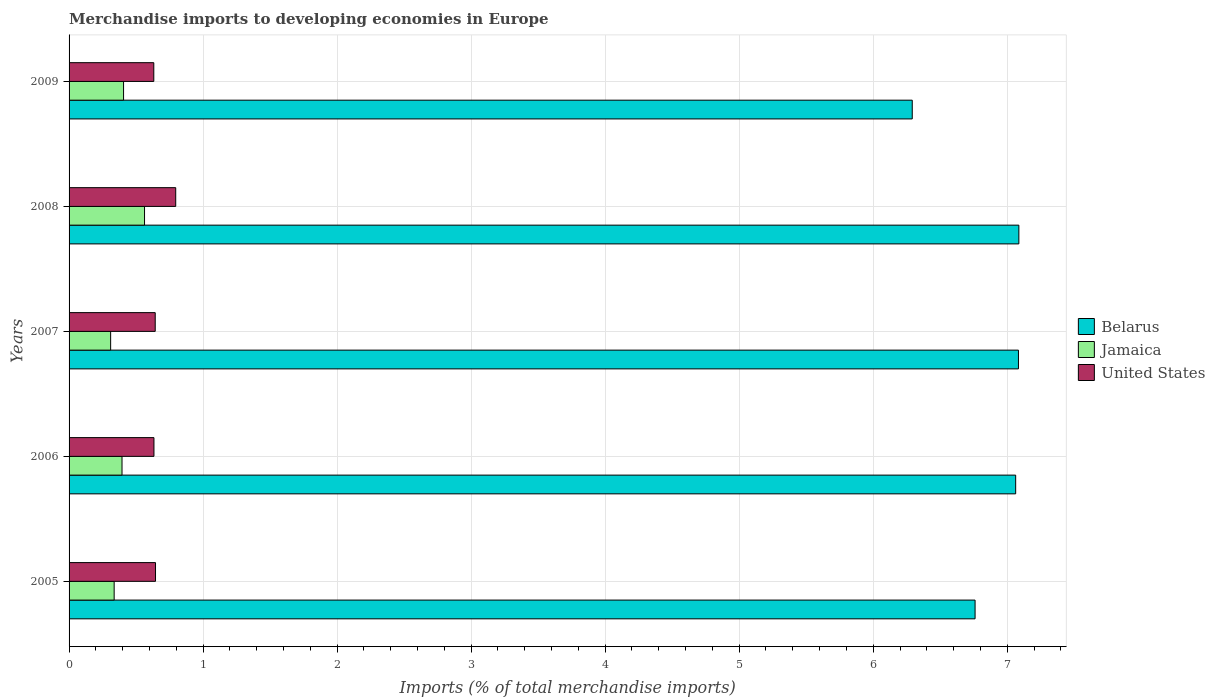How many different coloured bars are there?
Your answer should be compact. 3. How many groups of bars are there?
Ensure brevity in your answer.  5. How many bars are there on the 2nd tick from the bottom?
Give a very brief answer. 3. What is the label of the 1st group of bars from the top?
Keep it short and to the point. 2009. In how many cases, is the number of bars for a given year not equal to the number of legend labels?
Provide a succinct answer. 0. What is the percentage total merchandise imports in Belarus in 2005?
Give a very brief answer. 6.76. Across all years, what is the maximum percentage total merchandise imports in Belarus?
Offer a very short reply. 7.09. Across all years, what is the minimum percentage total merchandise imports in Jamaica?
Provide a succinct answer. 0.31. In which year was the percentage total merchandise imports in United States maximum?
Offer a terse response. 2008. What is the total percentage total merchandise imports in Jamaica in the graph?
Your answer should be very brief. 2.01. What is the difference between the percentage total merchandise imports in Belarus in 2005 and that in 2009?
Keep it short and to the point. 0.47. What is the difference between the percentage total merchandise imports in United States in 2006 and the percentage total merchandise imports in Jamaica in 2009?
Your answer should be compact. 0.23. What is the average percentage total merchandise imports in Jamaica per year?
Ensure brevity in your answer.  0.4. In the year 2009, what is the difference between the percentage total merchandise imports in Jamaica and percentage total merchandise imports in United States?
Your answer should be compact. -0.23. What is the ratio of the percentage total merchandise imports in Jamaica in 2006 to that in 2008?
Offer a terse response. 0.7. What is the difference between the highest and the second highest percentage total merchandise imports in Belarus?
Provide a succinct answer. 0. What is the difference between the highest and the lowest percentage total merchandise imports in Jamaica?
Your answer should be compact. 0.25. Is the sum of the percentage total merchandise imports in Jamaica in 2005 and 2007 greater than the maximum percentage total merchandise imports in Belarus across all years?
Ensure brevity in your answer.  No. What does the 3rd bar from the top in 2005 represents?
Make the answer very short. Belarus. What does the 1st bar from the bottom in 2009 represents?
Make the answer very short. Belarus. Is it the case that in every year, the sum of the percentage total merchandise imports in Belarus and percentage total merchandise imports in United States is greater than the percentage total merchandise imports in Jamaica?
Your response must be concise. Yes. How many bars are there?
Make the answer very short. 15. How many years are there in the graph?
Your answer should be compact. 5. Are the values on the major ticks of X-axis written in scientific E-notation?
Offer a very short reply. No. Does the graph contain any zero values?
Offer a very short reply. No. Does the graph contain grids?
Give a very brief answer. Yes. How are the legend labels stacked?
Offer a very short reply. Vertical. What is the title of the graph?
Your answer should be compact. Merchandise imports to developing economies in Europe. Does "Mozambique" appear as one of the legend labels in the graph?
Give a very brief answer. No. What is the label or title of the X-axis?
Keep it short and to the point. Imports (% of total merchandise imports). What is the label or title of the Y-axis?
Make the answer very short. Years. What is the Imports (% of total merchandise imports) in Belarus in 2005?
Your answer should be compact. 6.76. What is the Imports (% of total merchandise imports) of Jamaica in 2005?
Provide a short and direct response. 0.34. What is the Imports (% of total merchandise imports) of United States in 2005?
Provide a short and direct response. 0.65. What is the Imports (% of total merchandise imports) of Belarus in 2006?
Your answer should be very brief. 7.06. What is the Imports (% of total merchandise imports) of Jamaica in 2006?
Make the answer very short. 0.39. What is the Imports (% of total merchandise imports) in United States in 2006?
Offer a very short reply. 0.63. What is the Imports (% of total merchandise imports) of Belarus in 2007?
Your answer should be very brief. 7.08. What is the Imports (% of total merchandise imports) of Jamaica in 2007?
Your answer should be compact. 0.31. What is the Imports (% of total merchandise imports) of United States in 2007?
Ensure brevity in your answer.  0.64. What is the Imports (% of total merchandise imports) in Belarus in 2008?
Keep it short and to the point. 7.09. What is the Imports (% of total merchandise imports) in Jamaica in 2008?
Ensure brevity in your answer.  0.56. What is the Imports (% of total merchandise imports) of United States in 2008?
Provide a short and direct response. 0.8. What is the Imports (% of total merchandise imports) of Belarus in 2009?
Your response must be concise. 6.29. What is the Imports (% of total merchandise imports) in Jamaica in 2009?
Your response must be concise. 0.41. What is the Imports (% of total merchandise imports) in United States in 2009?
Provide a short and direct response. 0.63. Across all years, what is the maximum Imports (% of total merchandise imports) in Belarus?
Provide a succinct answer. 7.09. Across all years, what is the maximum Imports (% of total merchandise imports) in Jamaica?
Your answer should be very brief. 0.56. Across all years, what is the maximum Imports (% of total merchandise imports) of United States?
Your response must be concise. 0.8. Across all years, what is the minimum Imports (% of total merchandise imports) of Belarus?
Your answer should be compact. 6.29. Across all years, what is the minimum Imports (% of total merchandise imports) in Jamaica?
Offer a terse response. 0.31. Across all years, what is the minimum Imports (% of total merchandise imports) of United States?
Offer a terse response. 0.63. What is the total Imports (% of total merchandise imports) of Belarus in the graph?
Your answer should be compact. 34.29. What is the total Imports (% of total merchandise imports) of Jamaica in the graph?
Provide a short and direct response. 2.01. What is the total Imports (% of total merchandise imports) in United States in the graph?
Make the answer very short. 3.35. What is the difference between the Imports (% of total merchandise imports) of Belarus in 2005 and that in 2006?
Offer a terse response. -0.3. What is the difference between the Imports (% of total merchandise imports) of Jamaica in 2005 and that in 2006?
Provide a short and direct response. -0.06. What is the difference between the Imports (% of total merchandise imports) of United States in 2005 and that in 2006?
Ensure brevity in your answer.  0.01. What is the difference between the Imports (% of total merchandise imports) of Belarus in 2005 and that in 2007?
Give a very brief answer. -0.32. What is the difference between the Imports (% of total merchandise imports) of Jamaica in 2005 and that in 2007?
Offer a very short reply. 0.03. What is the difference between the Imports (% of total merchandise imports) in United States in 2005 and that in 2007?
Your answer should be very brief. 0. What is the difference between the Imports (% of total merchandise imports) of Belarus in 2005 and that in 2008?
Ensure brevity in your answer.  -0.33. What is the difference between the Imports (% of total merchandise imports) in Jamaica in 2005 and that in 2008?
Give a very brief answer. -0.23. What is the difference between the Imports (% of total merchandise imports) in United States in 2005 and that in 2008?
Keep it short and to the point. -0.15. What is the difference between the Imports (% of total merchandise imports) of Belarus in 2005 and that in 2009?
Keep it short and to the point. 0.47. What is the difference between the Imports (% of total merchandise imports) of Jamaica in 2005 and that in 2009?
Keep it short and to the point. -0.07. What is the difference between the Imports (% of total merchandise imports) in United States in 2005 and that in 2009?
Give a very brief answer. 0.01. What is the difference between the Imports (% of total merchandise imports) of Belarus in 2006 and that in 2007?
Ensure brevity in your answer.  -0.02. What is the difference between the Imports (% of total merchandise imports) in Jamaica in 2006 and that in 2007?
Make the answer very short. 0.08. What is the difference between the Imports (% of total merchandise imports) of United States in 2006 and that in 2007?
Offer a very short reply. -0.01. What is the difference between the Imports (% of total merchandise imports) of Belarus in 2006 and that in 2008?
Your answer should be very brief. -0.02. What is the difference between the Imports (% of total merchandise imports) of Jamaica in 2006 and that in 2008?
Make the answer very short. -0.17. What is the difference between the Imports (% of total merchandise imports) of United States in 2006 and that in 2008?
Ensure brevity in your answer.  -0.16. What is the difference between the Imports (% of total merchandise imports) in Belarus in 2006 and that in 2009?
Provide a succinct answer. 0.77. What is the difference between the Imports (% of total merchandise imports) of Jamaica in 2006 and that in 2009?
Keep it short and to the point. -0.01. What is the difference between the Imports (% of total merchandise imports) in United States in 2006 and that in 2009?
Your answer should be very brief. 0. What is the difference between the Imports (% of total merchandise imports) in Belarus in 2007 and that in 2008?
Give a very brief answer. -0. What is the difference between the Imports (% of total merchandise imports) in Jamaica in 2007 and that in 2008?
Offer a terse response. -0.25. What is the difference between the Imports (% of total merchandise imports) of United States in 2007 and that in 2008?
Offer a terse response. -0.15. What is the difference between the Imports (% of total merchandise imports) of Belarus in 2007 and that in 2009?
Your answer should be very brief. 0.79. What is the difference between the Imports (% of total merchandise imports) in Jamaica in 2007 and that in 2009?
Your answer should be compact. -0.1. What is the difference between the Imports (% of total merchandise imports) of United States in 2007 and that in 2009?
Your answer should be very brief. 0.01. What is the difference between the Imports (% of total merchandise imports) in Belarus in 2008 and that in 2009?
Give a very brief answer. 0.8. What is the difference between the Imports (% of total merchandise imports) of Jamaica in 2008 and that in 2009?
Your answer should be compact. 0.16. What is the difference between the Imports (% of total merchandise imports) of United States in 2008 and that in 2009?
Your answer should be compact. 0.16. What is the difference between the Imports (% of total merchandise imports) of Belarus in 2005 and the Imports (% of total merchandise imports) of Jamaica in 2006?
Offer a terse response. 6.37. What is the difference between the Imports (% of total merchandise imports) in Belarus in 2005 and the Imports (% of total merchandise imports) in United States in 2006?
Make the answer very short. 6.13. What is the difference between the Imports (% of total merchandise imports) in Jamaica in 2005 and the Imports (% of total merchandise imports) in United States in 2006?
Your answer should be compact. -0.3. What is the difference between the Imports (% of total merchandise imports) in Belarus in 2005 and the Imports (% of total merchandise imports) in Jamaica in 2007?
Offer a very short reply. 6.45. What is the difference between the Imports (% of total merchandise imports) in Belarus in 2005 and the Imports (% of total merchandise imports) in United States in 2007?
Your answer should be compact. 6.12. What is the difference between the Imports (% of total merchandise imports) of Jamaica in 2005 and the Imports (% of total merchandise imports) of United States in 2007?
Your response must be concise. -0.31. What is the difference between the Imports (% of total merchandise imports) in Belarus in 2005 and the Imports (% of total merchandise imports) in Jamaica in 2008?
Keep it short and to the point. 6.2. What is the difference between the Imports (% of total merchandise imports) of Belarus in 2005 and the Imports (% of total merchandise imports) of United States in 2008?
Offer a terse response. 5.96. What is the difference between the Imports (% of total merchandise imports) in Jamaica in 2005 and the Imports (% of total merchandise imports) in United States in 2008?
Ensure brevity in your answer.  -0.46. What is the difference between the Imports (% of total merchandise imports) of Belarus in 2005 and the Imports (% of total merchandise imports) of Jamaica in 2009?
Your answer should be compact. 6.35. What is the difference between the Imports (% of total merchandise imports) in Belarus in 2005 and the Imports (% of total merchandise imports) in United States in 2009?
Your answer should be compact. 6.13. What is the difference between the Imports (% of total merchandise imports) in Jamaica in 2005 and the Imports (% of total merchandise imports) in United States in 2009?
Your response must be concise. -0.3. What is the difference between the Imports (% of total merchandise imports) of Belarus in 2006 and the Imports (% of total merchandise imports) of Jamaica in 2007?
Keep it short and to the point. 6.75. What is the difference between the Imports (% of total merchandise imports) of Belarus in 2006 and the Imports (% of total merchandise imports) of United States in 2007?
Provide a succinct answer. 6.42. What is the difference between the Imports (% of total merchandise imports) of Jamaica in 2006 and the Imports (% of total merchandise imports) of United States in 2007?
Provide a succinct answer. -0.25. What is the difference between the Imports (% of total merchandise imports) in Belarus in 2006 and the Imports (% of total merchandise imports) in Jamaica in 2008?
Provide a succinct answer. 6.5. What is the difference between the Imports (% of total merchandise imports) of Belarus in 2006 and the Imports (% of total merchandise imports) of United States in 2008?
Make the answer very short. 6.27. What is the difference between the Imports (% of total merchandise imports) in Jamaica in 2006 and the Imports (% of total merchandise imports) in United States in 2008?
Provide a short and direct response. -0.4. What is the difference between the Imports (% of total merchandise imports) in Belarus in 2006 and the Imports (% of total merchandise imports) in Jamaica in 2009?
Offer a very short reply. 6.66. What is the difference between the Imports (% of total merchandise imports) of Belarus in 2006 and the Imports (% of total merchandise imports) of United States in 2009?
Keep it short and to the point. 6.43. What is the difference between the Imports (% of total merchandise imports) in Jamaica in 2006 and the Imports (% of total merchandise imports) in United States in 2009?
Offer a terse response. -0.24. What is the difference between the Imports (% of total merchandise imports) in Belarus in 2007 and the Imports (% of total merchandise imports) in Jamaica in 2008?
Make the answer very short. 6.52. What is the difference between the Imports (% of total merchandise imports) in Belarus in 2007 and the Imports (% of total merchandise imports) in United States in 2008?
Your response must be concise. 6.29. What is the difference between the Imports (% of total merchandise imports) of Jamaica in 2007 and the Imports (% of total merchandise imports) of United States in 2008?
Give a very brief answer. -0.49. What is the difference between the Imports (% of total merchandise imports) in Belarus in 2007 and the Imports (% of total merchandise imports) in Jamaica in 2009?
Offer a terse response. 6.68. What is the difference between the Imports (% of total merchandise imports) of Belarus in 2007 and the Imports (% of total merchandise imports) of United States in 2009?
Provide a short and direct response. 6.45. What is the difference between the Imports (% of total merchandise imports) of Jamaica in 2007 and the Imports (% of total merchandise imports) of United States in 2009?
Give a very brief answer. -0.32. What is the difference between the Imports (% of total merchandise imports) of Belarus in 2008 and the Imports (% of total merchandise imports) of Jamaica in 2009?
Ensure brevity in your answer.  6.68. What is the difference between the Imports (% of total merchandise imports) in Belarus in 2008 and the Imports (% of total merchandise imports) in United States in 2009?
Give a very brief answer. 6.45. What is the difference between the Imports (% of total merchandise imports) of Jamaica in 2008 and the Imports (% of total merchandise imports) of United States in 2009?
Give a very brief answer. -0.07. What is the average Imports (% of total merchandise imports) in Belarus per year?
Offer a very short reply. 6.86. What is the average Imports (% of total merchandise imports) of Jamaica per year?
Offer a terse response. 0.4. What is the average Imports (% of total merchandise imports) in United States per year?
Offer a very short reply. 0.67. In the year 2005, what is the difference between the Imports (% of total merchandise imports) of Belarus and Imports (% of total merchandise imports) of Jamaica?
Ensure brevity in your answer.  6.42. In the year 2005, what is the difference between the Imports (% of total merchandise imports) in Belarus and Imports (% of total merchandise imports) in United States?
Provide a short and direct response. 6.12. In the year 2005, what is the difference between the Imports (% of total merchandise imports) of Jamaica and Imports (% of total merchandise imports) of United States?
Your response must be concise. -0.31. In the year 2006, what is the difference between the Imports (% of total merchandise imports) in Belarus and Imports (% of total merchandise imports) in Jamaica?
Provide a succinct answer. 6.67. In the year 2006, what is the difference between the Imports (% of total merchandise imports) in Belarus and Imports (% of total merchandise imports) in United States?
Give a very brief answer. 6.43. In the year 2006, what is the difference between the Imports (% of total merchandise imports) in Jamaica and Imports (% of total merchandise imports) in United States?
Provide a short and direct response. -0.24. In the year 2007, what is the difference between the Imports (% of total merchandise imports) in Belarus and Imports (% of total merchandise imports) in Jamaica?
Offer a very short reply. 6.77. In the year 2007, what is the difference between the Imports (% of total merchandise imports) of Belarus and Imports (% of total merchandise imports) of United States?
Provide a short and direct response. 6.44. In the year 2007, what is the difference between the Imports (% of total merchandise imports) of Jamaica and Imports (% of total merchandise imports) of United States?
Offer a terse response. -0.33. In the year 2008, what is the difference between the Imports (% of total merchandise imports) in Belarus and Imports (% of total merchandise imports) in Jamaica?
Keep it short and to the point. 6.52. In the year 2008, what is the difference between the Imports (% of total merchandise imports) in Belarus and Imports (% of total merchandise imports) in United States?
Your answer should be very brief. 6.29. In the year 2008, what is the difference between the Imports (% of total merchandise imports) in Jamaica and Imports (% of total merchandise imports) in United States?
Offer a terse response. -0.23. In the year 2009, what is the difference between the Imports (% of total merchandise imports) of Belarus and Imports (% of total merchandise imports) of Jamaica?
Your answer should be compact. 5.88. In the year 2009, what is the difference between the Imports (% of total merchandise imports) of Belarus and Imports (% of total merchandise imports) of United States?
Provide a short and direct response. 5.66. In the year 2009, what is the difference between the Imports (% of total merchandise imports) in Jamaica and Imports (% of total merchandise imports) in United States?
Ensure brevity in your answer.  -0.23. What is the ratio of the Imports (% of total merchandise imports) of Belarus in 2005 to that in 2006?
Provide a short and direct response. 0.96. What is the ratio of the Imports (% of total merchandise imports) in Jamaica in 2005 to that in 2006?
Your answer should be compact. 0.85. What is the ratio of the Imports (% of total merchandise imports) in United States in 2005 to that in 2006?
Offer a terse response. 1.02. What is the ratio of the Imports (% of total merchandise imports) in Belarus in 2005 to that in 2007?
Give a very brief answer. 0.95. What is the ratio of the Imports (% of total merchandise imports) of Jamaica in 2005 to that in 2007?
Ensure brevity in your answer.  1.08. What is the ratio of the Imports (% of total merchandise imports) in Belarus in 2005 to that in 2008?
Provide a short and direct response. 0.95. What is the ratio of the Imports (% of total merchandise imports) of Jamaica in 2005 to that in 2008?
Provide a short and direct response. 0.6. What is the ratio of the Imports (% of total merchandise imports) in United States in 2005 to that in 2008?
Provide a succinct answer. 0.81. What is the ratio of the Imports (% of total merchandise imports) of Belarus in 2005 to that in 2009?
Your answer should be very brief. 1.07. What is the ratio of the Imports (% of total merchandise imports) in Jamaica in 2005 to that in 2009?
Your answer should be very brief. 0.83. What is the ratio of the Imports (% of total merchandise imports) in United States in 2005 to that in 2009?
Provide a succinct answer. 1.02. What is the ratio of the Imports (% of total merchandise imports) in Jamaica in 2006 to that in 2007?
Provide a short and direct response. 1.27. What is the ratio of the Imports (% of total merchandise imports) in United States in 2006 to that in 2007?
Provide a short and direct response. 0.99. What is the ratio of the Imports (% of total merchandise imports) of Jamaica in 2006 to that in 2008?
Keep it short and to the point. 0.7. What is the ratio of the Imports (% of total merchandise imports) in United States in 2006 to that in 2008?
Keep it short and to the point. 0.8. What is the ratio of the Imports (% of total merchandise imports) of Belarus in 2006 to that in 2009?
Offer a very short reply. 1.12. What is the ratio of the Imports (% of total merchandise imports) in Jamaica in 2006 to that in 2009?
Your answer should be compact. 0.97. What is the ratio of the Imports (% of total merchandise imports) in United States in 2006 to that in 2009?
Ensure brevity in your answer.  1. What is the ratio of the Imports (% of total merchandise imports) of Jamaica in 2007 to that in 2008?
Offer a terse response. 0.55. What is the ratio of the Imports (% of total merchandise imports) of United States in 2007 to that in 2008?
Offer a very short reply. 0.81. What is the ratio of the Imports (% of total merchandise imports) in Belarus in 2007 to that in 2009?
Your response must be concise. 1.13. What is the ratio of the Imports (% of total merchandise imports) in Jamaica in 2007 to that in 2009?
Your answer should be very brief. 0.76. What is the ratio of the Imports (% of total merchandise imports) of United States in 2007 to that in 2009?
Make the answer very short. 1.02. What is the ratio of the Imports (% of total merchandise imports) in Belarus in 2008 to that in 2009?
Make the answer very short. 1.13. What is the ratio of the Imports (% of total merchandise imports) of Jamaica in 2008 to that in 2009?
Your answer should be compact. 1.38. What is the ratio of the Imports (% of total merchandise imports) of United States in 2008 to that in 2009?
Give a very brief answer. 1.26. What is the difference between the highest and the second highest Imports (% of total merchandise imports) of Belarus?
Ensure brevity in your answer.  0. What is the difference between the highest and the second highest Imports (% of total merchandise imports) of Jamaica?
Your answer should be compact. 0.16. What is the difference between the highest and the second highest Imports (% of total merchandise imports) of United States?
Give a very brief answer. 0.15. What is the difference between the highest and the lowest Imports (% of total merchandise imports) of Belarus?
Your answer should be compact. 0.8. What is the difference between the highest and the lowest Imports (% of total merchandise imports) in Jamaica?
Your response must be concise. 0.25. What is the difference between the highest and the lowest Imports (% of total merchandise imports) in United States?
Make the answer very short. 0.16. 